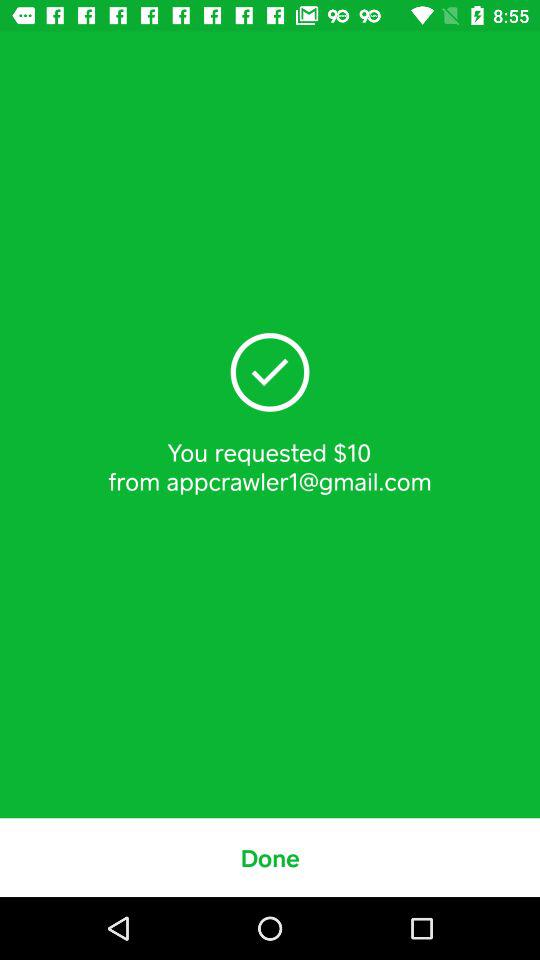How much money have I requested? You have requested $10. 